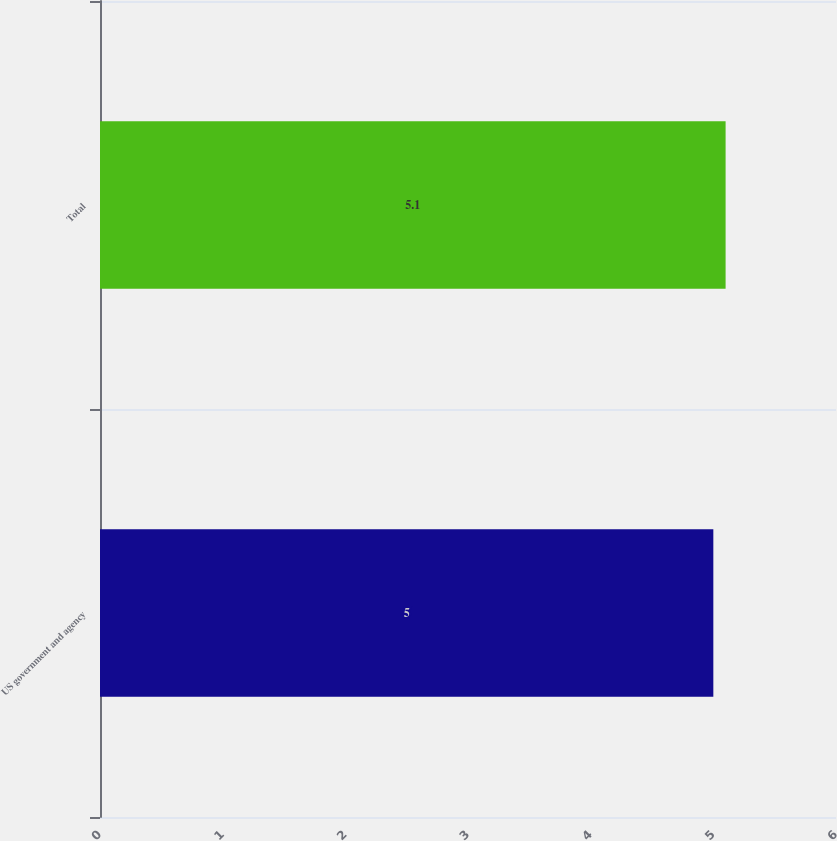Convert chart. <chart><loc_0><loc_0><loc_500><loc_500><bar_chart><fcel>US government and agency<fcel>Total<nl><fcel>5<fcel>5.1<nl></chart> 